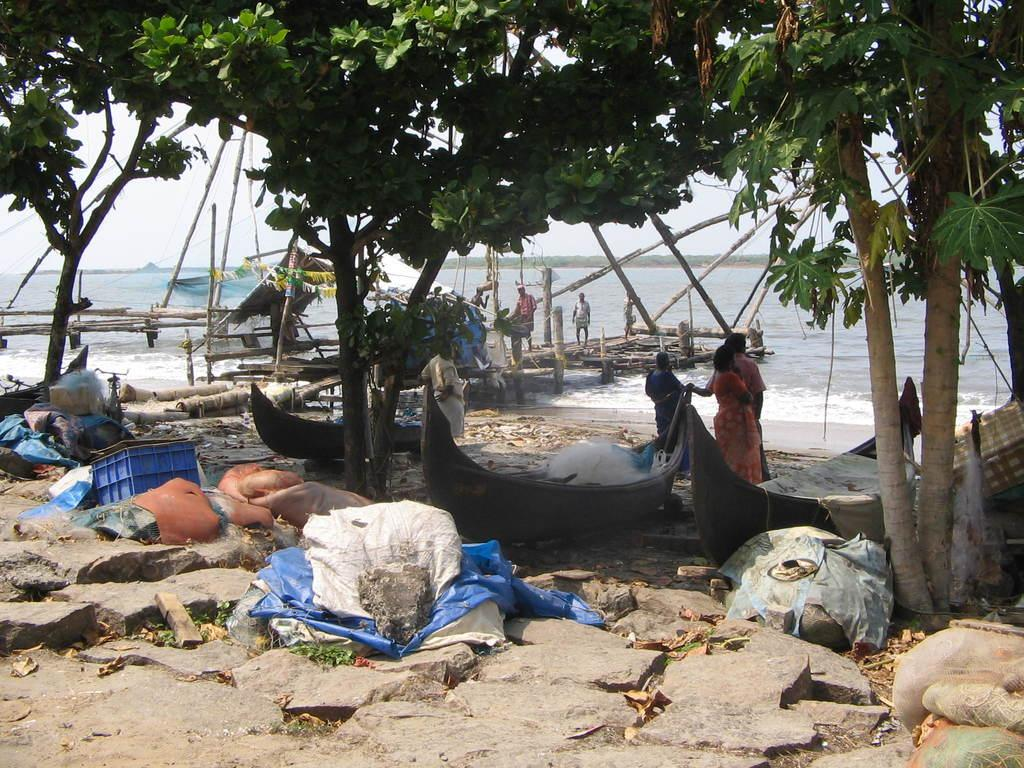What can be seen in the image involving people? There are people standing in the image. What natural element is visible in the image? Water is visible in the image. What type of transportation can be seen in the image? There are boats in the image. What type of geological feature is present in the image? There are rocks in the image. What part of the natural environment is visible in the image? The sky is visible in the image. What type of vegetation is present in the image? Trees are present in the image. Where is the mailbox located in the image? There is no mailbox present in the image. What type of medical facility can be seen in the image? There is no hospital present in the image. 